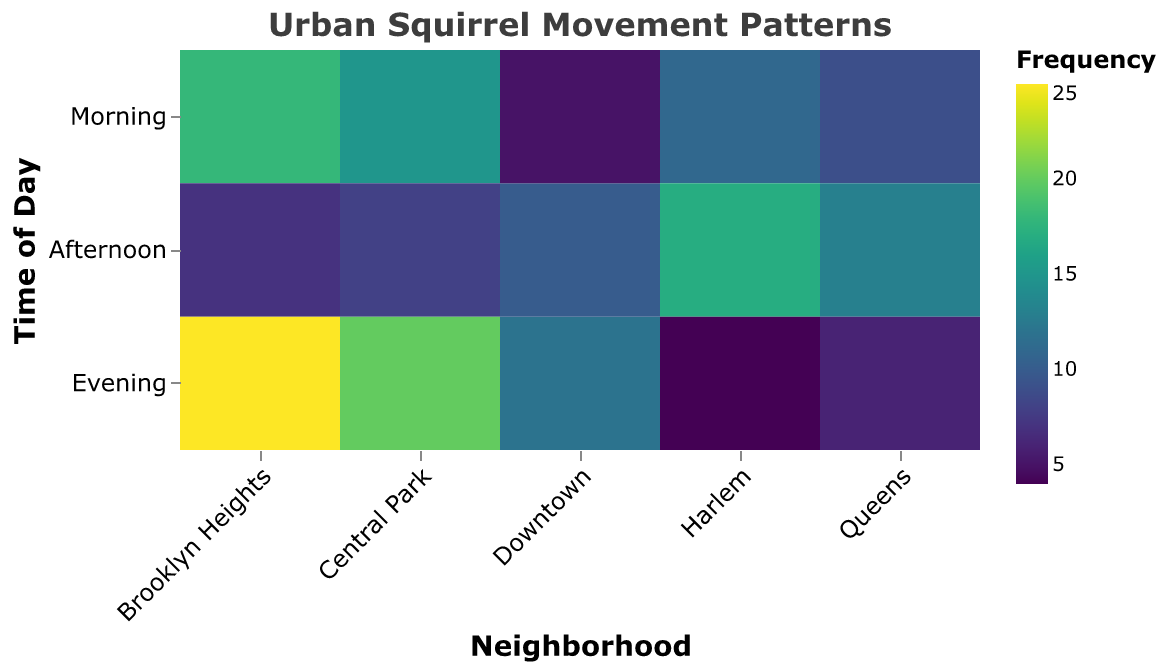What is the title of the heatmap? The title is located at the top center of the heatmap. It reads: "Urban Squirrel Movement Patterns".
Answer: Urban Squirrel Movement Patterns Which neighborhood has the highest frequency during the evening? By looking at the color intensity in the evening row, "Brooklyn Heights" has the darkest color in its cell, indicating the highest frequency. The tooltip shows the exact value of 25.
Answer: Brooklyn Heights What time of day has the fewest total squirrel movements in Central Park? To determine this, we compare the colors in the three time-of-day cells for Central Park (Morning: 15, Afternoon: 8, Evening: 20). The afternoon cell has the lightest color, showing the fewest movements.
Answer: Afternoon Which location in Harlem has the highest squirrel activity? In the Harlem row, we compare the colors/intensities. The Public Plaza cell has the darkest color, indicating the highest activity frequency of 17.
Answer: Public Plaza What is the total frequency of squirrel movements in Downtown across all times of day? Sum the frequencies for all Downtown locations: Morning (5) + Afternoon (10) + Evening (12) = 27.
Answer: 27 Between morning and afternoon in Brooklyn Heights, which time has a higher squirrel movement frequency? Comparing the morning (18) and afternoon (7) cells in Brooklyn Heights, the morning cell is darker, showing a higher frequency.
Answer: Morning Are there any locations with zero squirrel movements? There are no cells with the lightest possible color, implying every cell has some level of activity.
Answer: No Which neighborhood shows the most varied squirrel movement patterns across different times of day, and how can you tell? One way to measure variability is by looking at the range of color intensities within a neighborhood. Harlem shows more variability with frequencies ranging from 4 (Library Steps) to 17 (Public Plaza).
Answer: Harlem In which neighborhood and at what time of day do squirrels visit the park entrance most frequently? The Park Entrance location is found in Central Park during the evening with a frequency of 20, indicated by a relatively dark color.
Answer: Central Park, Evening 